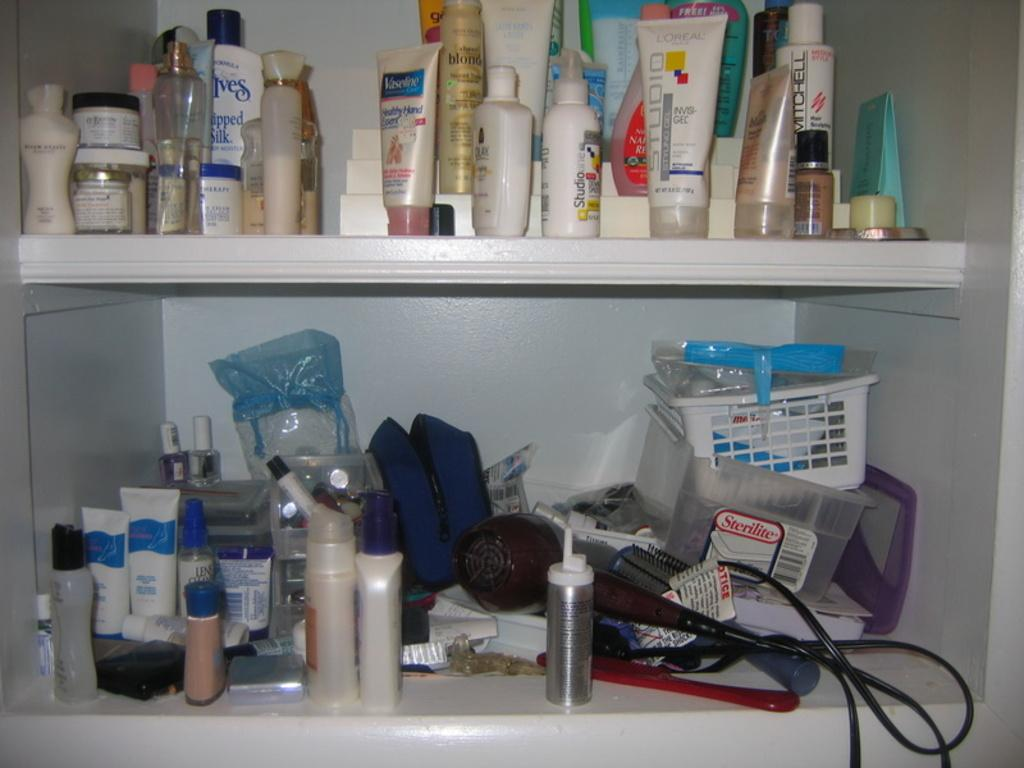<image>
Share a concise interpretation of the image provided. A bathroom pantry with a Sterilite container in it 